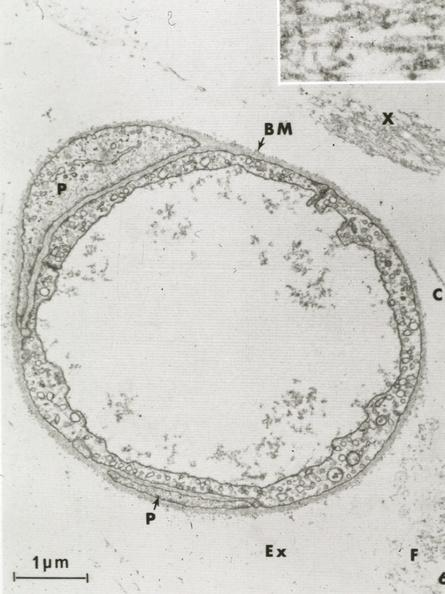s cardiovascular present?
Answer the question using a single word or phrase. Yes 